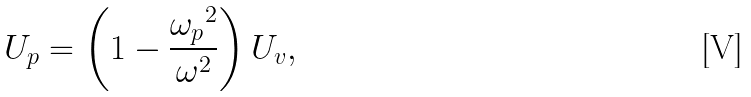<formula> <loc_0><loc_0><loc_500><loc_500>U _ { p } = \left ( 1 - \frac { { \omega _ { p } } ^ { 2 } } { \omega ^ { 2 } } \right ) U _ { v } ,</formula> 